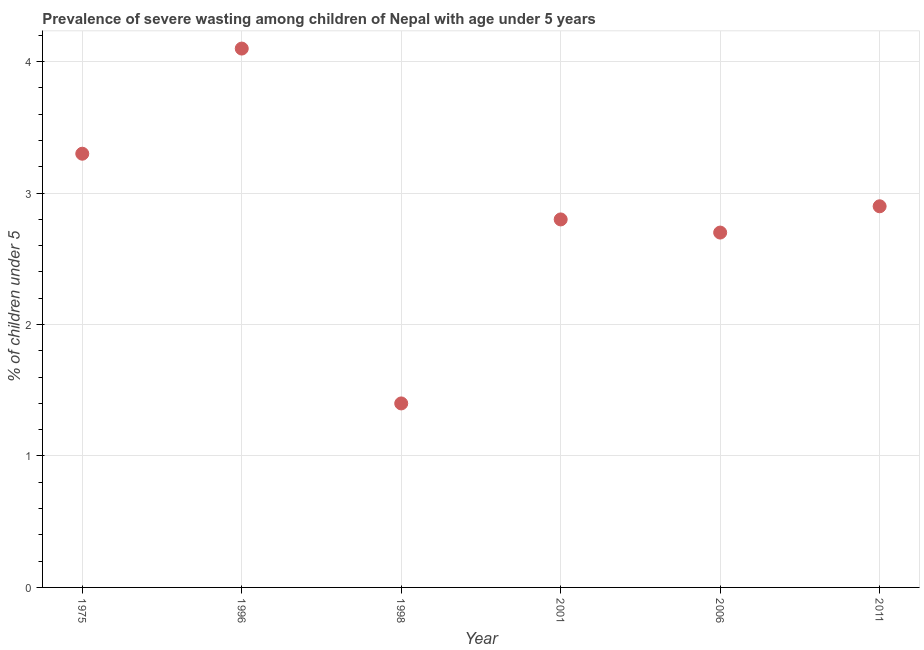What is the prevalence of severe wasting in 1996?
Your answer should be very brief. 4.1. Across all years, what is the maximum prevalence of severe wasting?
Ensure brevity in your answer.  4.1. Across all years, what is the minimum prevalence of severe wasting?
Make the answer very short. 1.4. In which year was the prevalence of severe wasting maximum?
Ensure brevity in your answer.  1996. In which year was the prevalence of severe wasting minimum?
Offer a terse response. 1998. What is the sum of the prevalence of severe wasting?
Offer a very short reply. 17.2. What is the difference between the prevalence of severe wasting in 1975 and 2011?
Your answer should be compact. 0.4. What is the average prevalence of severe wasting per year?
Your answer should be very brief. 2.87. What is the median prevalence of severe wasting?
Provide a succinct answer. 2.85. In how many years, is the prevalence of severe wasting greater than 0.2 %?
Your response must be concise. 6. What is the ratio of the prevalence of severe wasting in 1996 to that in 2006?
Provide a short and direct response. 1.52. Is the prevalence of severe wasting in 1975 less than that in 2011?
Your answer should be very brief. No. What is the difference between the highest and the second highest prevalence of severe wasting?
Your response must be concise. 0.8. What is the difference between the highest and the lowest prevalence of severe wasting?
Provide a short and direct response. 2.7. Does the prevalence of severe wasting monotonically increase over the years?
Offer a terse response. No. How many dotlines are there?
Make the answer very short. 1. How many years are there in the graph?
Provide a succinct answer. 6. What is the difference between two consecutive major ticks on the Y-axis?
Your answer should be compact. 1. Are the values on the major ticks of Y-axis written in scientific E-notation?
Provide a succinct answer. No. Does the graph contain grids?
Make the answer very short. Yes. What is the title of the graph?
Your answer should be compact. Prevalence of severe wasting among children of Nepal with age under 5 years. What is the label or title of the X-axis?
Your answer should be very brief. Year. What is the label or title of the Y-axis?
Give a very brief answer.  % of children under 5. What is the  % of children under 5 in 1975?
Make the answer very short. 3.3. What is the  % of children under 5 in 1996?
Your response must be concise. 4.1. What is the  % of children under 5 in 1998?
Give a very brief answer. 1.4. What is the  % of children under 5 in 2001?
Ensure brevity in your answer.  2.8. What is the  % of children under 5 in 2006?
Offer a very short reply. 2.7. What is the  % of children under 5 in 2011?
Your response must be concise. 2.9. What is the difference between the  % of children under 5 in 1975 and 1996?
Provide a succinct answer. -0.8. What is the difference between the  % of children under 5 in 1975 and 2011?
Keep it short and to the point. 0.4. What is the difference between the  % of children under 5 in 1996 and 2001?
Your answer should be compact. 1.3. What is the difference between the  % of children under 5 in 1996 and 2006?
Provide a short and direct response. 1.4. What is the difference between the  % of children under 5 in 1996 and 2011?
Give a very brief answer. 1.2. What is the difference between the  % of children under 5 in 1998 and 2001?
Offer a very short reply. -1.4. What is the difference between the  % of children under 5 in 1998 and 2006?
Your response must be concise. -1.3. What is the difference between the  % of children under 5 in 2001 and 2006?
Ensure brevity in your answer.  0.1. What is the difference between the  % of children under 5 in 2001 and 2011?
Your response must be concise. -0.1. What is the ratio of the  % of children under 5 in 1975 to that in 1996?
Your response must be concise. 0.81. What is the ratio of the  % of children under 5 in 1975 to that in 1998?
Your response must be concise. 2.36. What is the ratio of the  % of children under 5 in 1975 to that in 2001?
Make the answer very short. 1.18. What is the ratio of the  % of children under 5 in 1975 to that in 2006?
Provide a succinct answer. 1.22. What is the ratio of the  % of children under 5 in 1975 to that in 2011?
Your answer should be very brief. 1.14. What is the ratio of the  % of children under 5 in 1996 to that in 1998?
Provide a succinct answer. 2.93. What is the ratio of the  % of children under 5 in 1996 to that in 2001?
Your answer should be very brief. 1.46. What is the ratio of the  % of children under 5 in 1996 to that in 2006?
Make the answer very short. 1.52. What is the ratio of the  % of children under 5 in 1996 to that in 2011?
Ensure brevity in your answer.  1.41. What is the ratio of the  % of children under 5 in 1998 to that in 2001?
Your response must be concise. 0.5. What is the ratio of the  % of children under 5 in 1998 to that in 2006?
Ensure brevity in your answer.  0.52. What is the ratio of the  % of children under 5 in 1998 to that in 2011?
Make the answer very short. 0.48. What is the ratio of the  % of children under 5 in 2001 to that in 2006?
Your answer should be very brief. 1.04. What is the ratio of the  % of children under 5 in 2001 to that in 2011?
Offer a very short reply. 0.97. What is the ratio of the  % of children under 5 in 2006 to that in 2011?
Offer a very short reply. 0.93. 